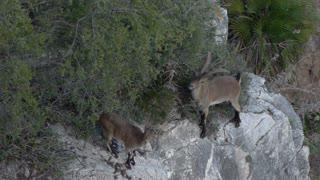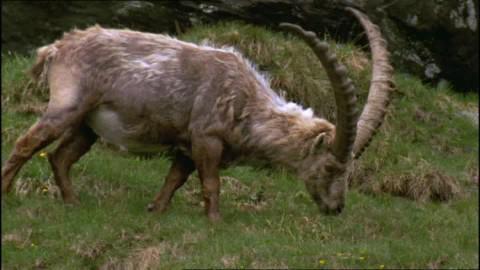The first image is the image on the left, the second image is the image on the right. For the images shown, is this caption "An image shows one right-facing horned animal with moulting coat, standing in a green grassy area." true? Answer yes or no. Yes. 